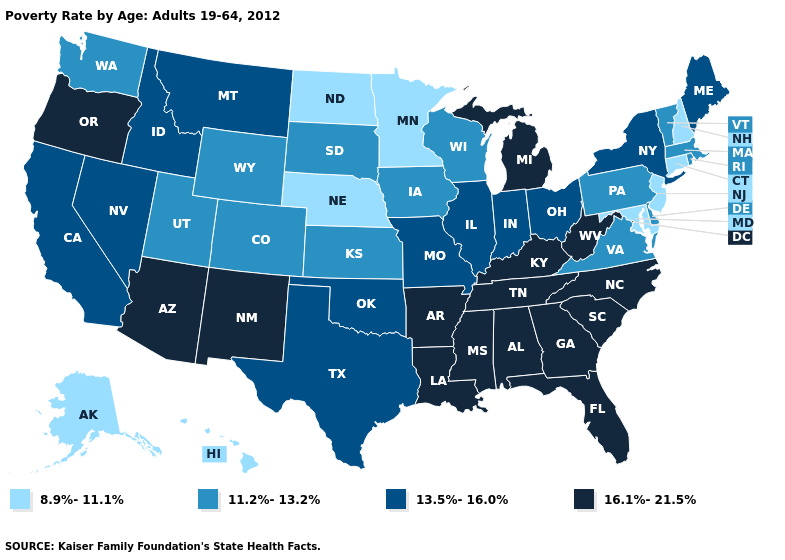What is the lowest value in states that border Florida?
Write a very short answer. 16.1%-21.5%. What is the value of Kansas?
Be succinct. 11.2%-13.2%. What is the value of New York?
Answer briefly. 13.5%-16.0%. Name the states that have a value in the range 11.2%-13.2%?
Be succinct. Colorado, Delaware, Iowa, Kansas, Massachusetts, Pennsylvania, Rhode Island, South Dakota, Utah, Vermont, Virginia, Washington, Wisconsin, Wyoming. Does Arkansas have the same value as Wyoming?
Concise answer only. No. What is the value of Tennessee?
Quick response, please. 16.1%-21.5%. Does the map have missing data?
Short answer required. No. Name the states that have a value in the range 16.1%-21.5%?
Be succinct. Alabama, Arizona, Arkansas, Florida, Georgia, Kentucky, Louisiana, Michigan, Mississippi, New Mexico, North Carolina, Oregon, South Carolina, Tennessee, West Virginia. What is the value of Nebraska?
Give a very brief answer. 8.9%-11.1%. Does Ohio have the same value as Oklahoma?
Write a very short answer. Yes. Name the states that have a value in the range 8.9%-11.1%?
Be succinct. Alaska, Connecticut, Hawaii, Maryland, Minnesota, Nebraska, New Hampshire, New Jersey, North Dakota. What is the value of Hawaii?
Short answer required. 8.9%-11.1%. Does Colorado have the highest value in the USA?
Be succinct. No. Among the states that border Arkansas , does Oklahoma have the lowest value?
Keep it brief. Yes. 